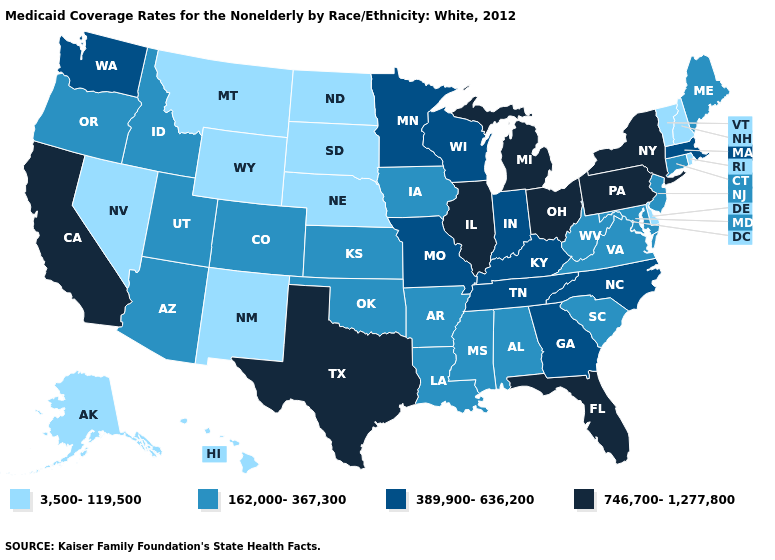What is the value of Vermont?
Give a very brief answer. 3,500-119,500. Does Michigan have a higher value than North Carolina?
Quick response, please. Yes. Is the legend a continuous bar?
Answer briefly. No. Among the states that border Alabama , which have the lowest value?
Give a very brief answer. Mississippi. What is the lowest value in states that border Connecticut?
Give a very brief answer. 3,500-119,500. Which states hav the highest value in the Northeast?
Quick response, please. New York, Pennsylvania. What is the value of Missouri?
Short answer required. 389,900-636,200. Is the legend a continuous bar?
Write a very short answer. No. Does West Virginia have the highest value in the USA?
Keep it brief. No. Name the states that have a value in the range 389,900-636,200?
Quick response, please. Georgia, Indiana, Kentucky, Massachusetts, Minnesota, Missouri, North Carolina, Tennessee, Washington, Wisconsin. What is the highest value in the South ?
Concise answer only. 746,700-1,277,800. Does New Hampshire have the highest value in the Northeast?
Give a very brief answer. No. Does Washington have a lower value than Oregon?
Give a very brief answer. No. What is the value of Vermont?
Short answer required. 3,500-119,500. 